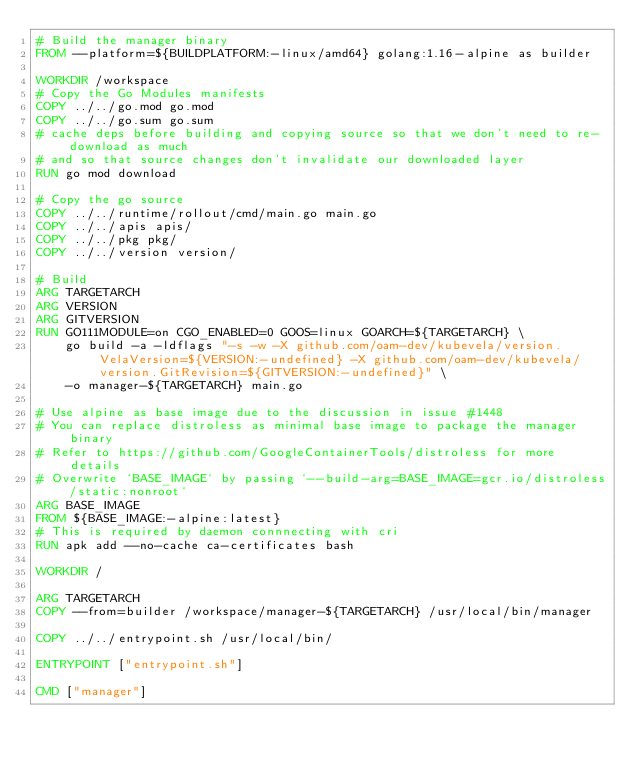Convert code to text. <code><loc_0><loc_0><loc_500><loc_500><_Dockerfile_># Build the manager binary
FROM --platform=${BUILDPLATFORM:-linux/amd64} golang:1.16-alpine as builder

WORKDIR /workspace
# Copy the Go Modules manifests
COPY ../../go.mod go.mod
COPY ../../go.sum go.sum
# cache deps before building and copying source so that we don't need to re-download as much
# and so that source changes don't invalidate our downloaded layer
RUN go mod download

# Copy the go source
COPY ../../runtime/rollout/cmd/main.go main.go
COPY ../../apis apis/
COPY ../../pkg pkg/
COPY ../../version version/

# Build
ARG TARGETARCH
ARG VERSION
ARG GITVERSION
RUN GO111MODULE=on CGO_ENABLED=0 GOOS=linux GOARCH=${TARGETARCH} \
    go build -a -ldflags "-s -w -X github.com/oam-dev/kubevela/version.VelaVersion=${VERSION:-undefined} -X github.com/oam-dev/kubevela/version.GitRevision=${GITVERSION:-undefined}" \
    -o manager-${TARGETARCH} main.go

# Use alpine as base image due to the discussion in issue #1448
# You can replace distroless as minimal base image to package the manager binary
# Refer to https://github.com/GoogleContainerTools/distroless for more details
# Overwrite `BASE_IMAGE` by passing `--build-arg=BASE_IMAGE=gcr.io/distroless/static:nonroot`
ARG BASE_IMAGE
FROM ${BASE_IMAGE:-alpine:latest}
# This is required by daemon connnecting with cri
RUN apk add --no-cache ca-certificates bash

WORKDIR /

ARG TARGETARCH
COPY --from=builder /workspace/manager-${TARGETARCH} /usr/local/bin/manager

COPY ../../entrypoint.sh /usr/local/bin/

ENTRYPOINT ["entrypoint.sh"]

CMD ["manager"]
</code> 